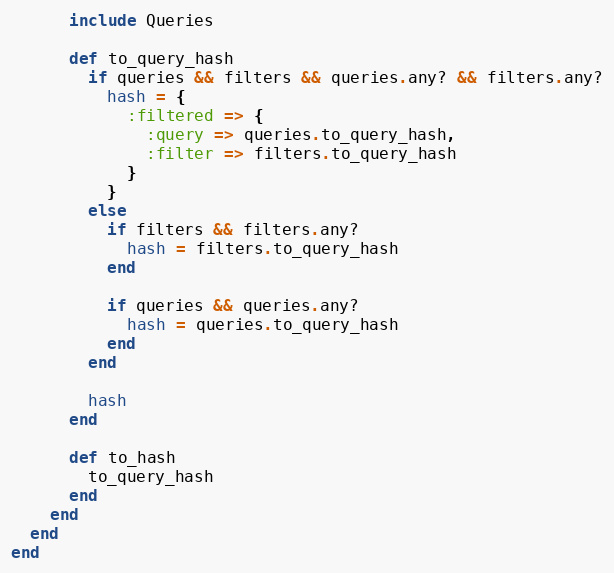Convert code to text. <code><loc_0><loc_0><loc_500><loc_500><_Ruby_>      include Queries

      def to_query_hash
        if queries && filters && queries.any? && filters.any?
          hash = {
            :filtered => {
              :query => queries.to_query_hash,
              :filter => filters.to_query_hash
            }
          }
        else
          if filters && filters.any?
            hash = filters.to_query_hash
          end

          if queries && queries.any?
            hash = queries.to_query_hash
          end
        end

        hash
      end

      def to_hash
        to_query_hash
      end
    end
  end
end</code> 